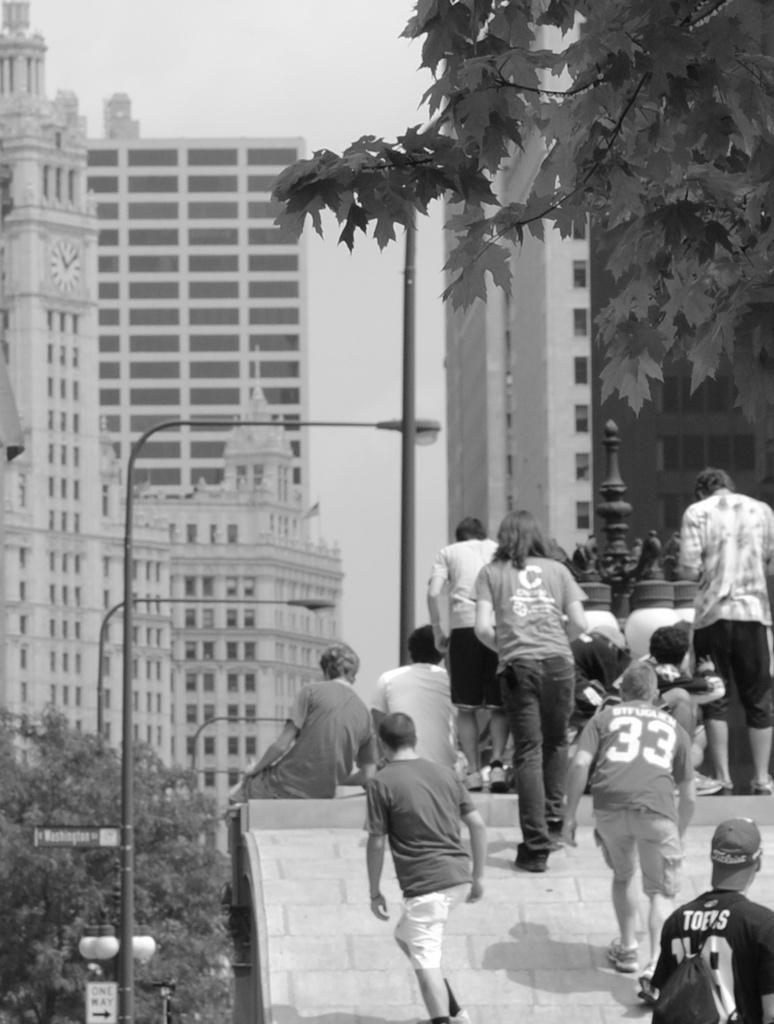<image>
Create a compact narrative representing the image presented. People walking near some buildings with one person wearing a 33 jersey. 